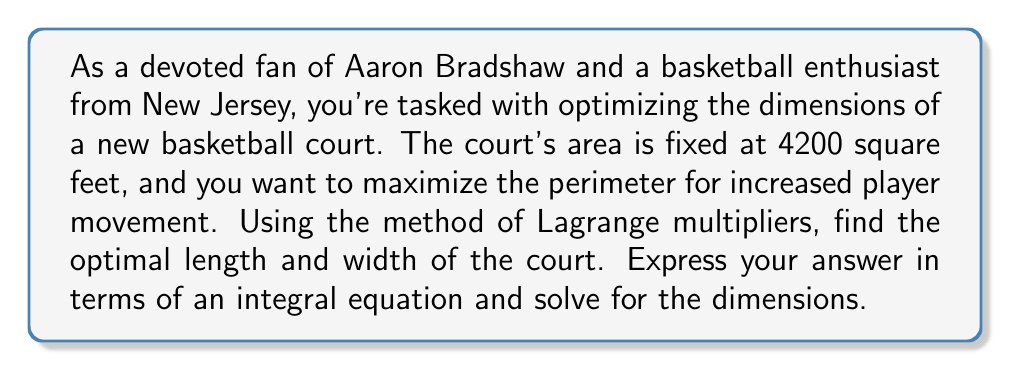Help me with this question. Let's approach this step-by-step:

1) Let $l$ be the length and $w$ be the width of the court.

2) We want to maximize the perimeter $P = 2l + 2w$ subject to the constraint that the area $A = lw = 4200$.

3) Using the method of Lagrange multipliers, we form the function:

   $$F(l, w, \lambda) = 2l + 2w - \lambda(lw - 4200)$$

4) Taking partial derivatives and setting them to zero:

   $$\frac{\partial F}{\partial l} = 2 - \lambda w = 0$$
   $$\frac{\partial F}{\partial w} = 2 - \lambda l = 0$$
   $$\frac{\partial F}{\partial \lambda} = lw - 4200 = 0$$

5) From the first two equations, we can see that $l = w$.

6) Substituting this into the third equation:

   $$l^2 = 4200$$

7) Solving for $l$ and $w$:

   $$l = w = \sqrt{4200} = 20\sqrt{21} \approx 64.81$$

8) To express this as an integral equation, we can use the fact that the optimal solution occurs when the length equals the width. We can write this as:

   $$\int_0^l 1 \, dx = \int_0^w 1 \, dy$$

9) Substituting the constraint $lw = 4200$:

   $$\int_0^l 1 \, dx = \int_0^{4200/l} 1 \, dy$$

This integral equation, along with the constraint $lw = 4200$, fully defines the optimal solution.
Answer: $\int_0^l 1 \, dx = \int_0^{4200/l} 1 \, dy$; $l = w = 20\sqrt{21}$ feet 